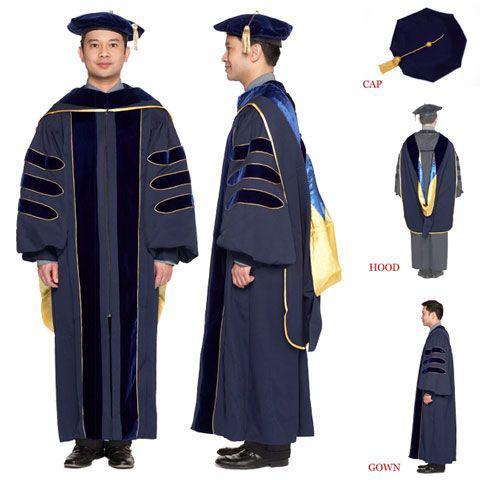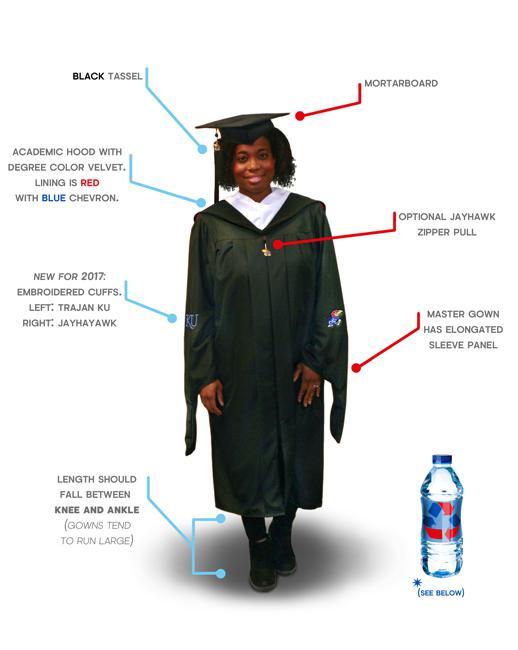The first image is the image on the left, the second image is the image on the right. Examine the images to the left and right. Is the description "At least one gown in the pair has a yellow part to the sash." accurate? Answer yes or no. Yes. 